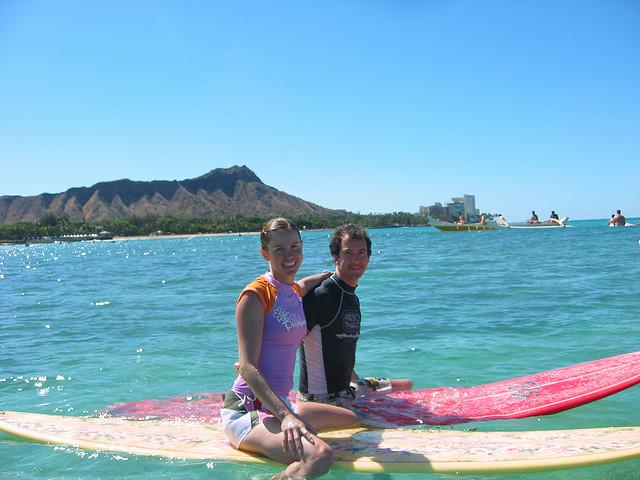Was this picture taken in Antarctica?
Quick response, please. No. Are these people married?
Write a very short answer. Yes. What are the people in the front riding on?
Give a very brief answer. Surfboards. 